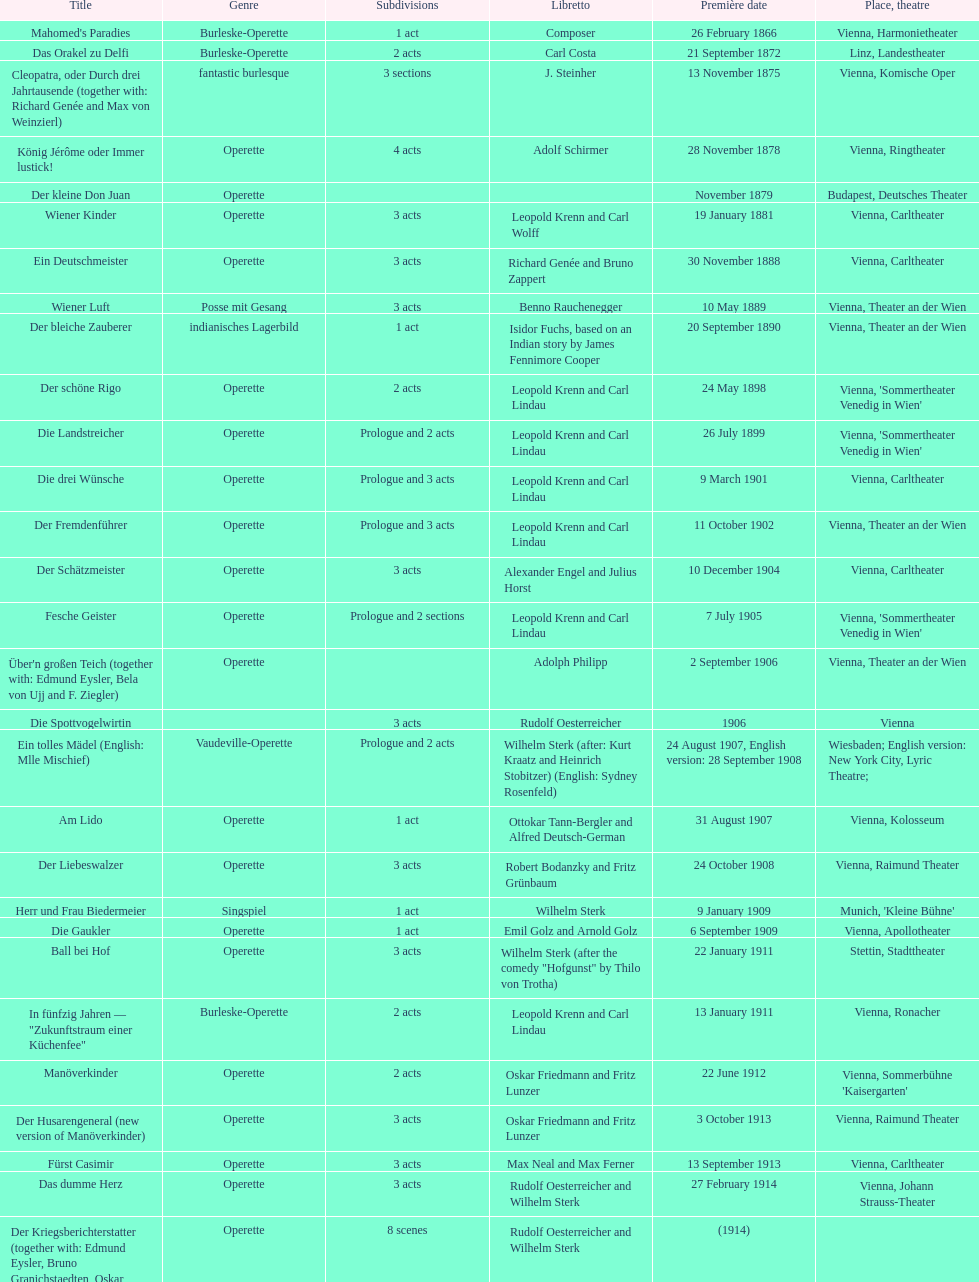Which type is predominantly displayed in this chart? Operette. 